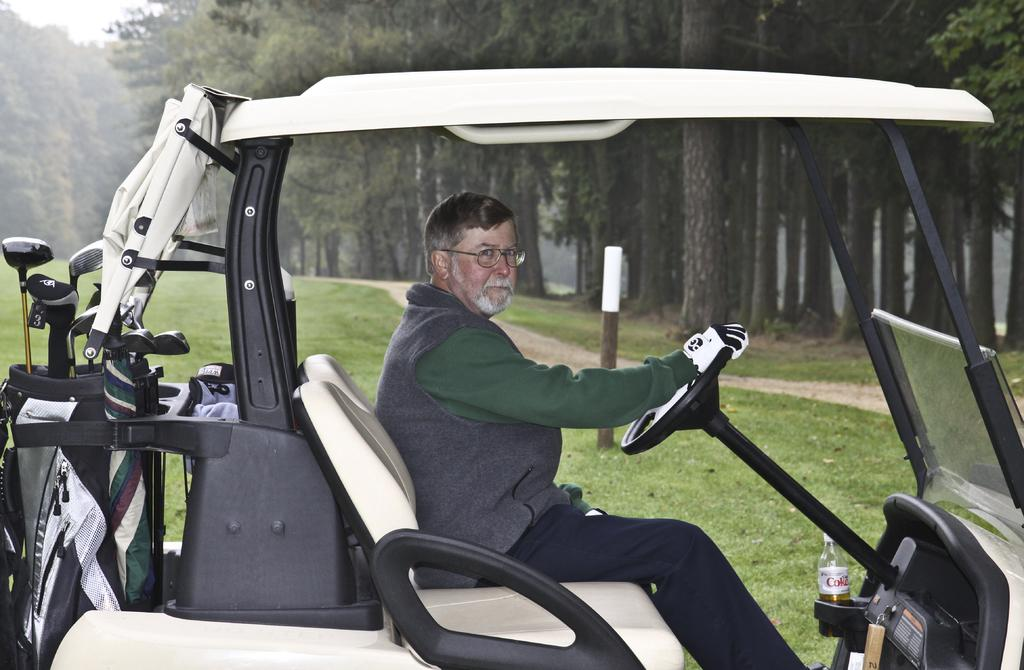What is the person in the image doing? There is a person sitting in a vehicle in the image. What type of equipment is present in the image? Golf bats are present in a bag in the image. What is the bottle visible in the image used for? The purpose of the bottle visible in the image is not specified, but it could be for drinking or holding liquid. What can be seen in the background of the image? There is a pole and trees visible in the background of the image. What type of terrain is present in the image? Grass is present on the ground in the image. Where is the kettle located in the image? There is no kettle present in the image. What type of key is used to unlock the golf bats in the image? There is no mention of a key or the need to unlock the golf bats in the image. 